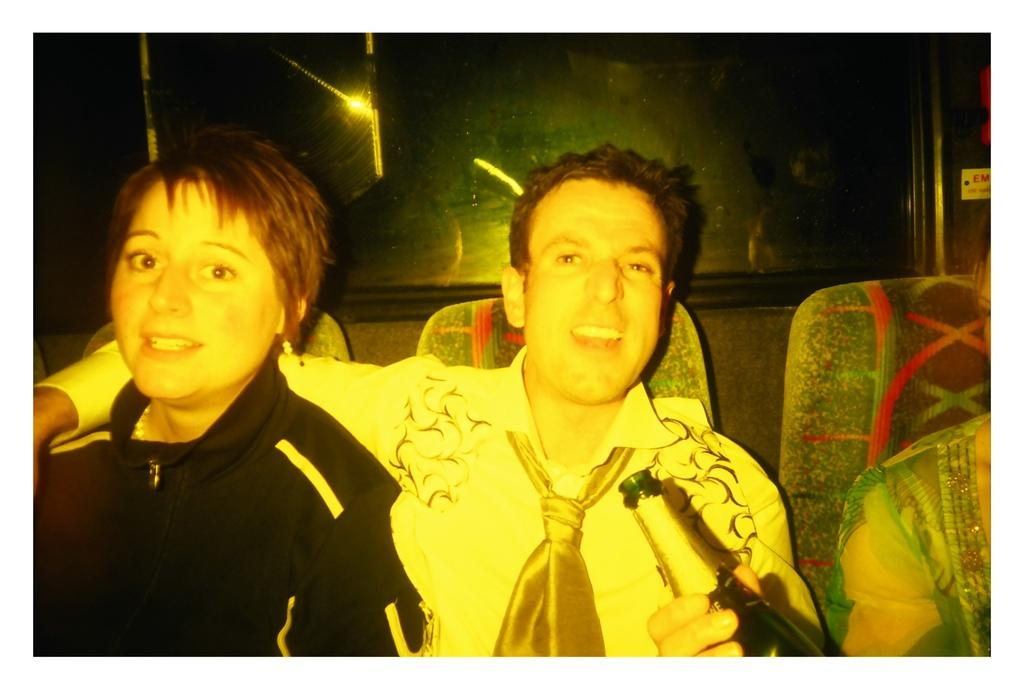How many people are in the image? There are three people in the image. What are the people doing in the image? The people are sitting on chairs. What can be seen behind the people in the image? There is a wall with a glass window behind the people. What type of coast can be seen in the image? There is no coast visible in the image; it features three people sitting on chairs with a wall and glass window behind them. 